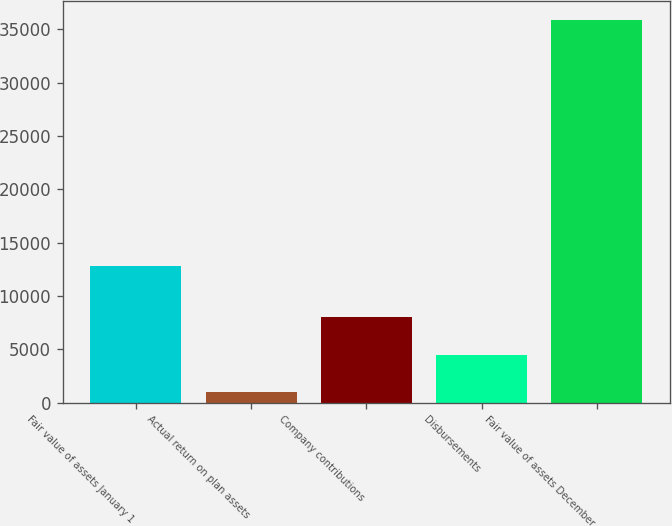Convert chart to OTSL. <chart><loc_0><loc_0><loc_500><loc_500><bar_chart><fcel>Fair value of assets January 1<fcel>Actual return on plan assets<fcel>Company contributions<fcel>Disbursements<fcel>Fair value of assets December<nl><fcel>12798<fcel>1007<fcel>7977.4<fcel>4492.2<fcel>35859<nl></chart> 